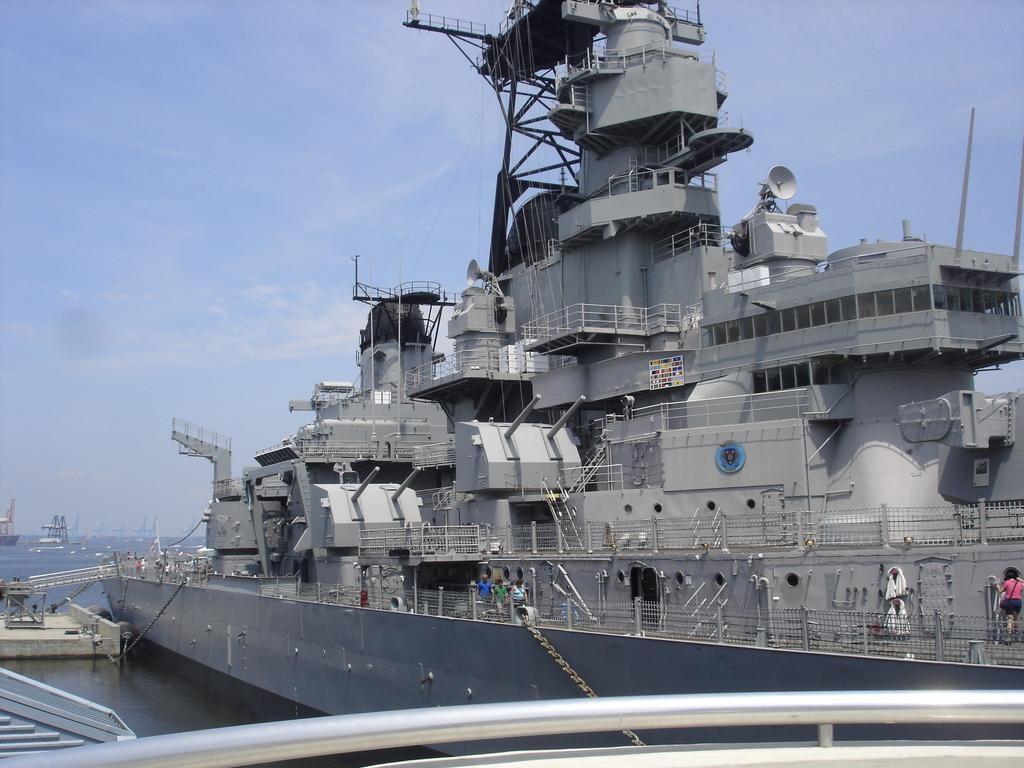How would you summarize this image in a sentence or two? In this image there is a ship, there are people walking on the ship,there is sea,there is sky. 